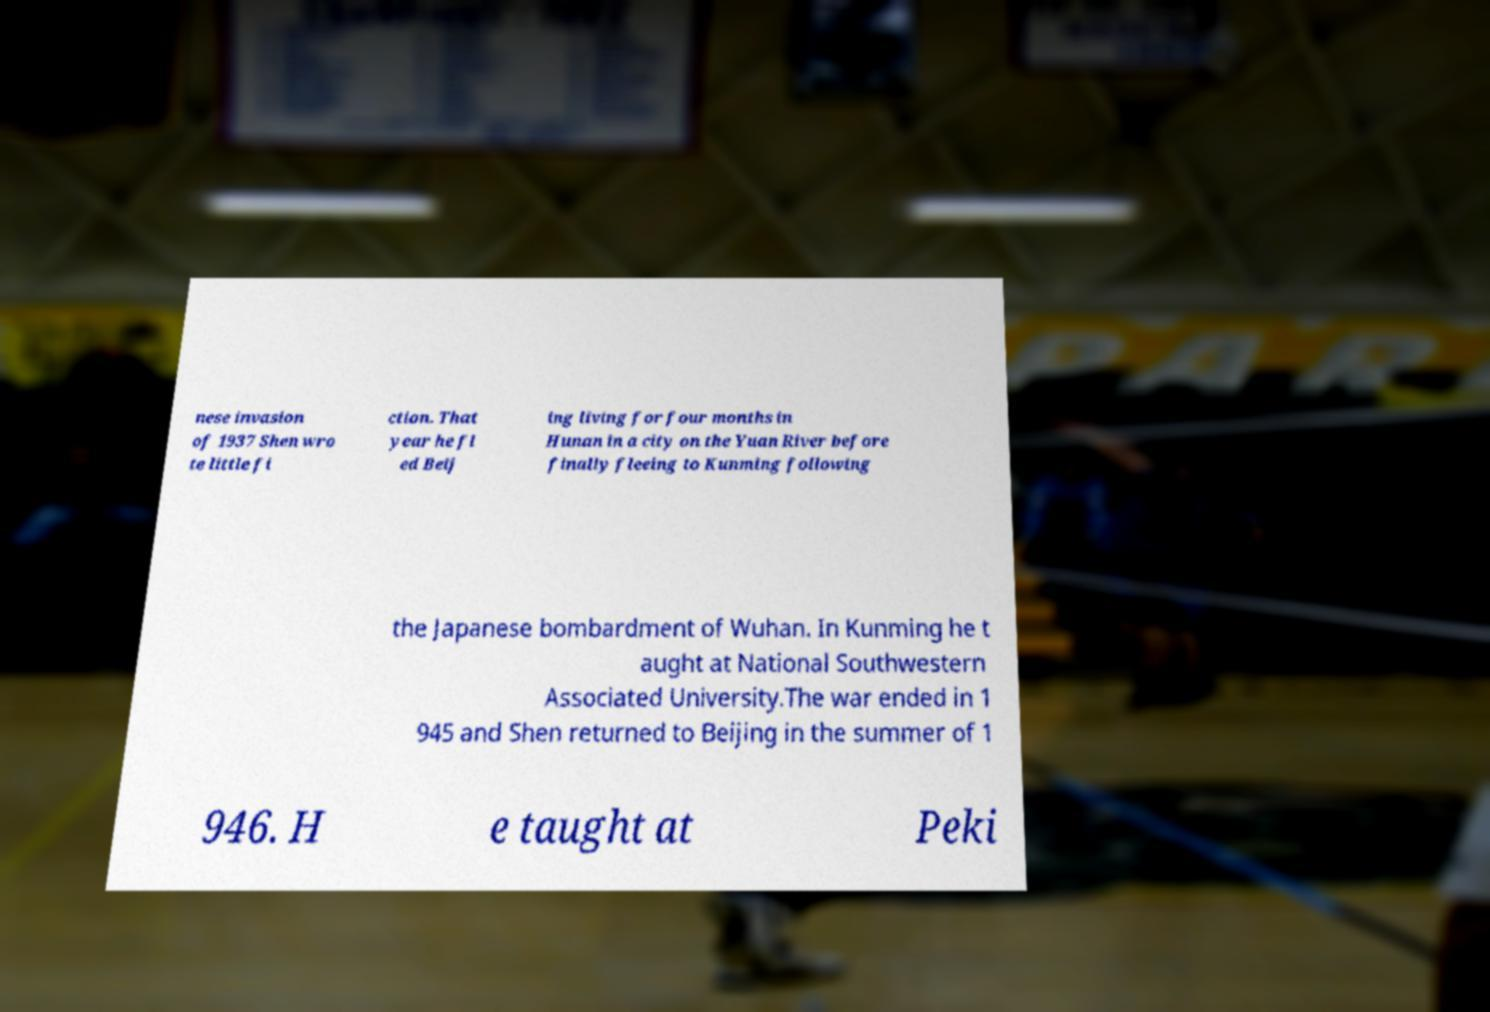Can you accurately transcribe the text from the provided image for me? nese invasion of 1937 Shen wro te little fi ction. That year he fl ed Beij ing living for four months in Hunan in a city on the Yuan River before finally fleeing to Kunming following the Japanese bombardment of Wuhan. In Kunming he t aught at National Southwestern Associated University.The war ended in 1 945 and Shen returned to Beijing in the summer of 1 946. H e taught at Peki 